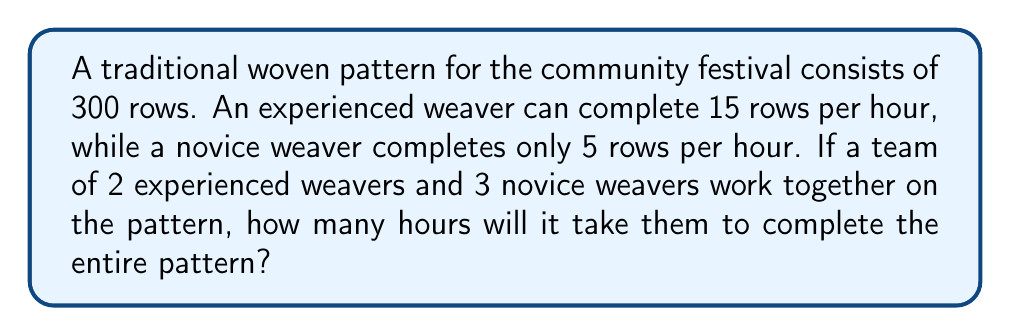What is the answer to this math problem? Let's approach this step-by-step:

1) First, calculate the total rows completed per hour by the experienced weavers:
   $2 \text{ weavers} \times 15 \text{ rows/hour} = 30 \text{ rows/hour}$

2) Next, calculate the total rows completed per hour by the novice weavers:
   $3 \text{ weavers} \times 5 \text{ rows/hour} = 15 \text{ rows/hour}$

3) Now, find the total rows completed per hour by the entire team:
   $30 \text{ rows/hour} + 15 \text{ rows/hour} = 45 \text{ rows/hour}$

4) To find the time required, we use the formula:
   $\text{Time} = \frac{\text{Total work}}{\text{Work rate}}$

5) Substituting our values:
   $\text{Time} = \frac{300 \text{ rows}}{45 \text{ rows/hour}}$

6) Simplify:
   $\text{Time} = \frac{300}{45} = \frac{20}{3} = 6\frac{2}{3} \text{ hours}$

Therefore, it will take the team 6 hours and 40 minutes to complete the pattern.
Answer: $6\frac{2}{3}$ hours 